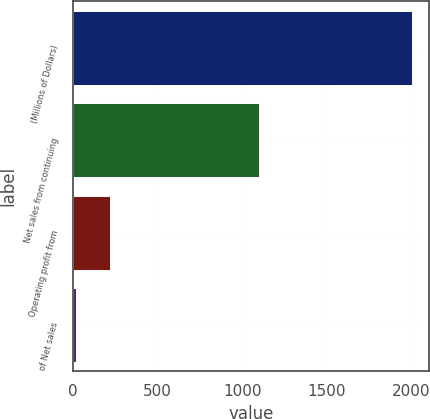<chart> <loc_0><loc_0><loc_500><loc_500><bar_chart><fcel>(Millions of Dollars)<fcel>Net sales from continuing<fcel>Operating profit from<fcel>of Net sales<nl><fcel>2005<fcel>1098<fcel>215.71<fcel>16.9<nl></chart> 